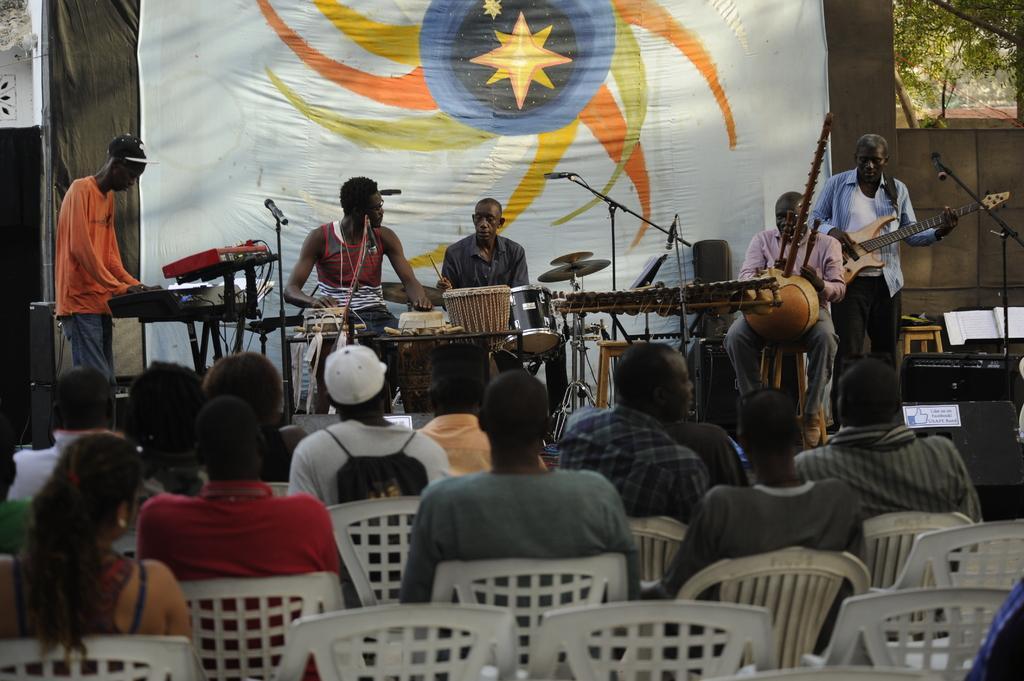Can you describe this image briefly? In this picture we can see some persons who are playing some musical instruments. On the background there is a banner. Here we can see some are sitting on the chairs. And these are the trees. 